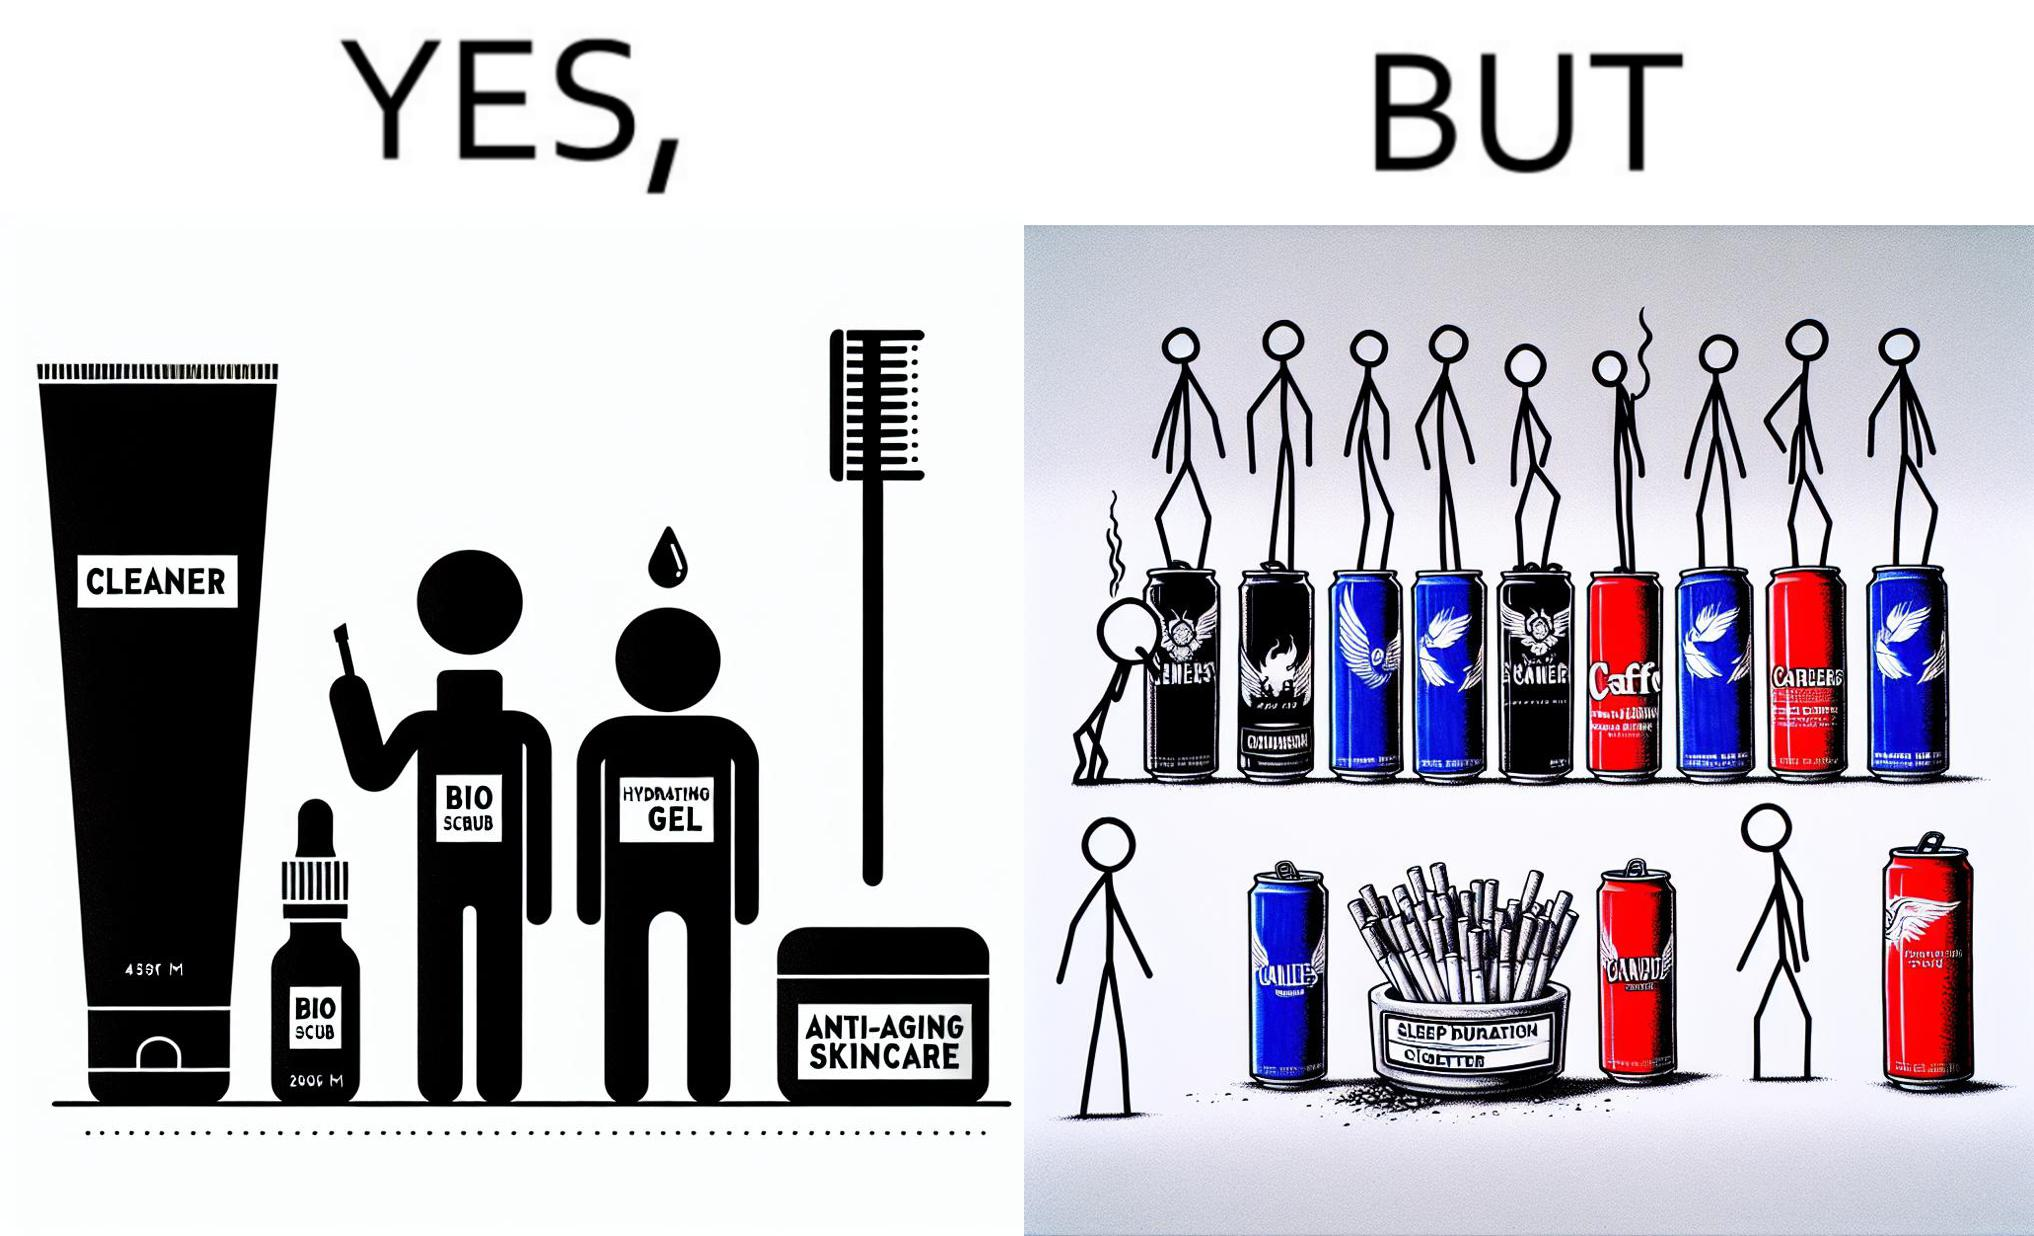What is the satirical meaning behind this image? This image is ironic as on the one hand, the presumed person is into skincare and wants to do the best for their skin, which is good, but on the other hand, they are involved in unhealthy habits that will damage their skin like smoking, caffeine and inadequate sleep. 